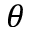<formula> <loc_0><loc_0><loc_500><loc_500>\theta</formula> 